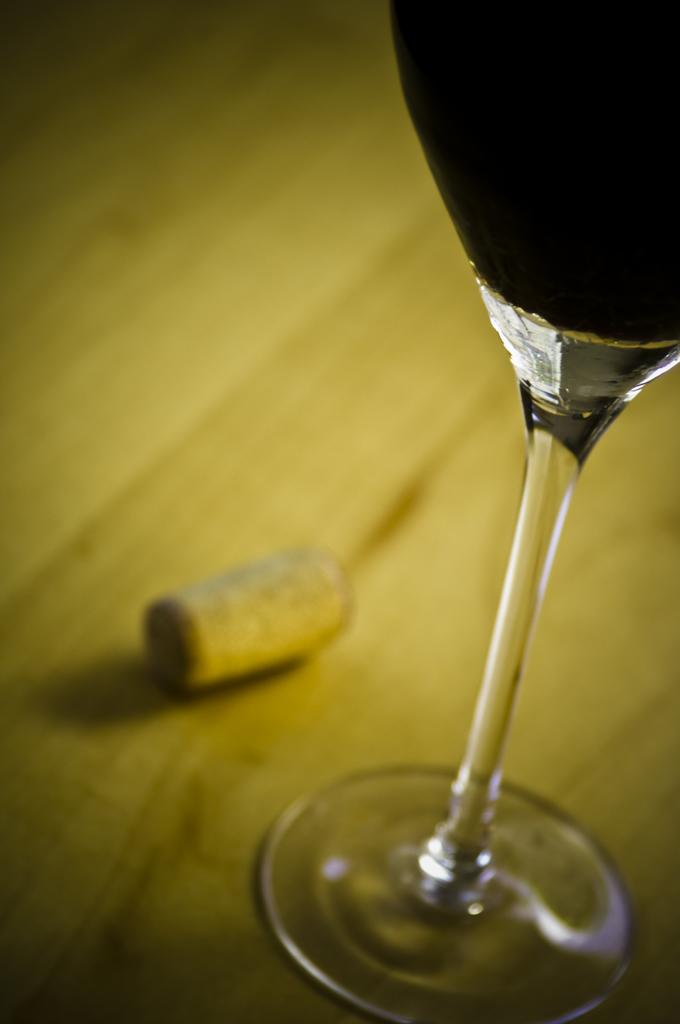What is in the glass that is visible in the image? The glass contains a drink. Where is the glass located in the image? The glass is on a platform. What type of heat can be felt coming from the wrist in the image? There is no wrist or heat present in the image; it only features a glass containing a drink on a platform. 